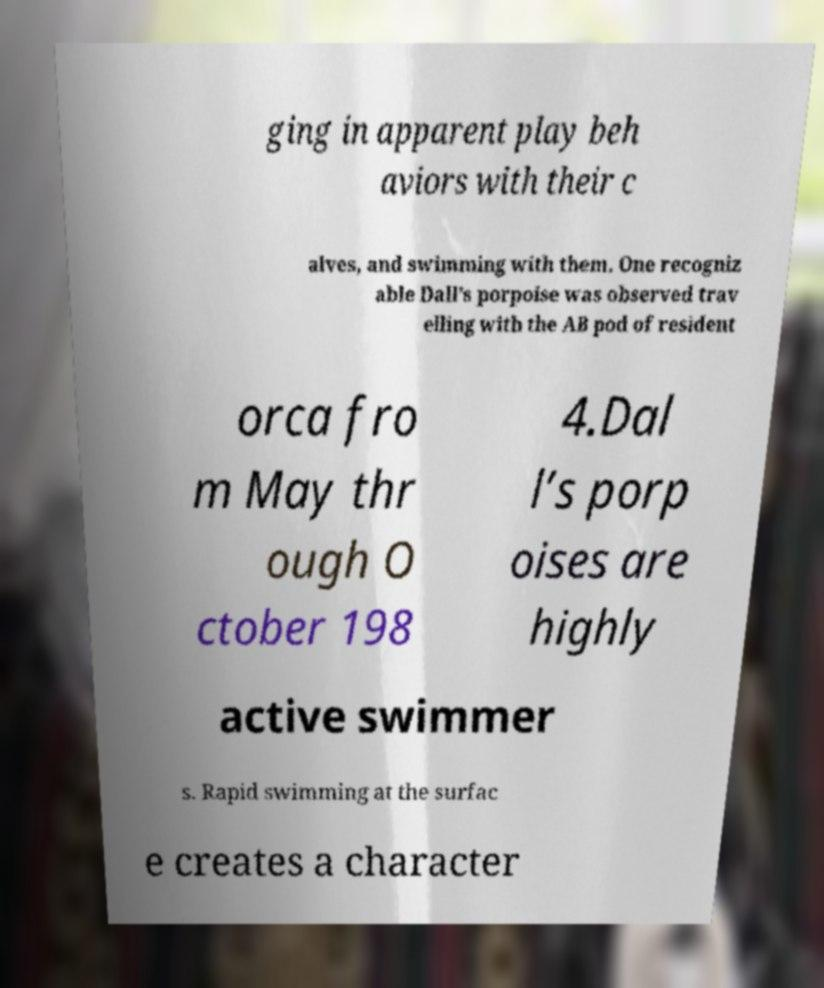Can you accurately transcribe the text from the provided image for me? ging in apparent play beh aviors with their c alves, and swimming with them. One recogniz able Dall’s porpoise was observed trav elling with the AB pod of resident orca fro m May thr ough O ctober 198 4.Dal l’s porp oises are highly active swimmer s. Rapid swimming at the surfac e creates a character 